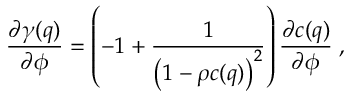<formula> <loc_0><loc_0><loc_500><loc_500>\frac { \partial \gamma ( q ) } { \partial \phi } = \left ( - 1 + \frac { 1 } { \left ( 1 - \rho c ( q ) \right ) ^ { 2 } } \right ) \frac { \partial c ( q ) } { \partial \phi } \, ,</formula> 